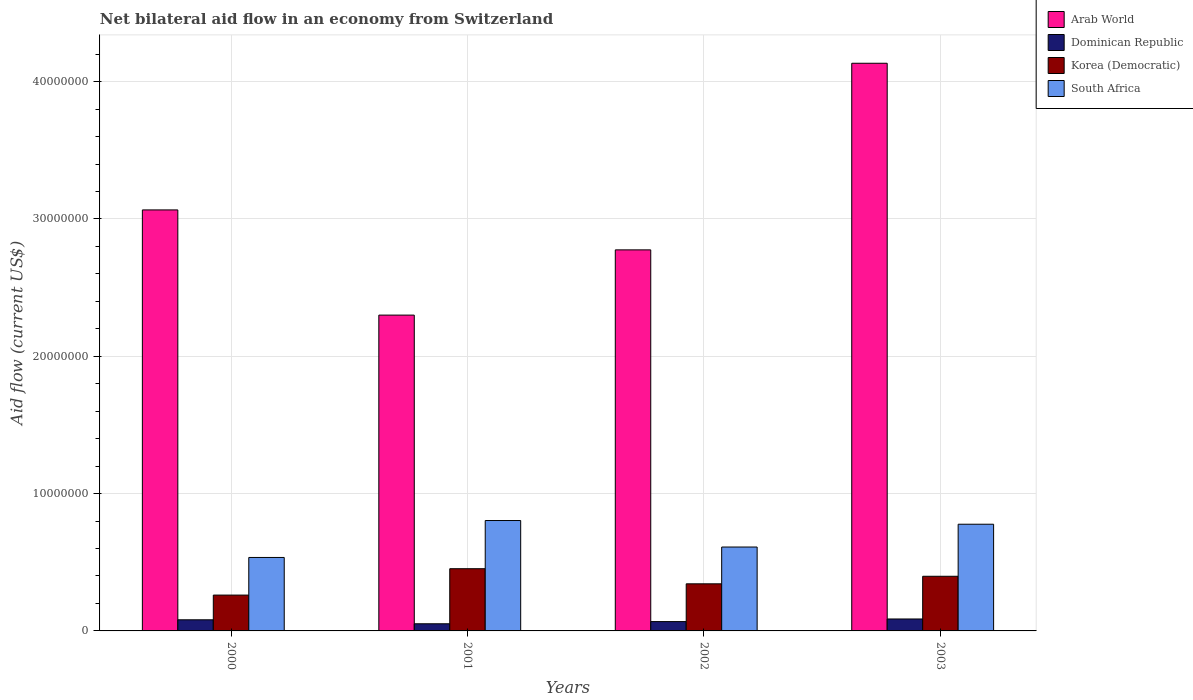How many different coloured bars are there?
Provide a succinct answer. 4. How many bars are there on the 1st tick from the left?
Ensure brevity in your answer.  4. In how many cases, is the number of bars for a given year not equal to the number of legend labels?
Provide a short and direct response. 0. What is the net bilateral aid flow in South Africa in 2002?
Your answer should be very brief. 6.11e+06. Across all years, what is the maximum net bilateral aid flow in South Africa?
Provide a short and direct response. 8.04e+06. Across all years, what is the minimum net bilateral aid flow in South Africa?
Keep it short and to the point. 5.35e+06. In which year was the net bilateral aid flow in Dominican Republic maximum?
Provide a succinct answer. 2003. In which year was the net bilateral aid flow in Korea (Democratic) minimum?
Your answer should be very brief. 2000. What is the total net bilateral aid flow in South Africa in the graph?
Offer a very short reply. 2.73e+07. What is the difference between the net bilateral aid flow in Korea (Democratic) in 2002 and that in 2003?
Offer a terse response. -5.50e+05. What is the difference between the net bilateral aid flow in South Africa in 2000 and the net bilateral aid flow in Arab World in 2003?
Your response must be concise. -3.60e+07. What is the average net bilateral aid flow in Arab World per year?
Your answer should be very brief. 3.07e+07. In the year 2000, what is the difference between the net bilateral aid flow in Dominican Republic and net bilateral aid flow in Arab World?
Offer a very short reply. -2.98e+07. In how many years, is the net bilateral aid flow in Korea (Democratic) greater than 4000000 US$?
Make the answer very short. 1. What is the ratio of the net bilateral aid flow in South Africa in 2001 to that in 2002?
Ensure brevity in your answer.  1.32. Is the net bilateral aid flow in Korea (Democratic) in 2001 less than that in 2003?
Your answer should be very brief. No. Is the difference between the net bilateral aid flow in Dominican Republic in 2000 and 2001 greater than the difference between the net bilateral aid flow in Arab World in 2000 and 2001?
Ensure brevity in your answer.  No. What is the difference between the highest and the lowest net bilateral aid flow in Korea (Democratic)?
Offer a terse response. 1.92e+06. What does the 3rd bar from the left in 2000 represents?
Your answer should be very brief. Korea (Democratic). What does the 1st bar from the right in 2003 represents?
Make the answer very short. South Africa. Is it the case that in every year, the sum of the net bilateral aid flow in South Africa and net bilateral aid flow in Dominican Republic is greater than the net bilateral aid flow in Korea (Democratic)?
Offer a very short reply. Yes. How many bars are there?
Offer a very short reply. 16. Are all the bars in the graph horizontal?
Offer a terse response. No. How many years are there in the graph?
Offer a terse response. 4. What is the difference between two consecutive major ticks on the Y-axis?
Your response must be concise. 1.00e+07. Are the values on the major ticks of Y-axis written in scientific E-notation?
Offer a terse response. No. Where does the legend appear in the graph?
Make the answer very short. Top right. How are the legend labels stacked?
Make the answer very short. Vertical. What is the title of the graph?
Make the answer very short. Net bilateral aid flow in an economy from Switzerland. What is the label or title of the Y-axis?
Your response must be concise. Aid flow (current US$). What is the Aid flow (current US$) in Arab World in 2000?
Your response must be concise. 3.07e+07. What is the Aid flow (current US$) of Dominican Republic in 2000?
Provide a short and direct response. 8.10e+05. What is the Aid flow (current US$) in Korea (Democratic) in 2000?
Make the answer very short. 2.61e+06. What is the Aid flow (current US$) of South Africa in 2000?
Your answer should be very brief. 5.35e+06. What is the Aid flow (current US$) in Arab World in 2001?
Ensure brevity in your answer.  2.30e+07. What is the Aid flow (current US$) of Dominican Republic in 2001?
Give a very brief answer. 5.20e+05. What is the Aid flow (current US$) of Korea (Democratic) in 2001?
Ensure brevity in your answer.  4.53e+06. What is the Aid flow (current US$) in South Africa in 2001?
Provide a short and direct response. 8.04e+06. What is the Aid flow (current US$) in Arab World in 2002?
Your answer should be very brief. 2.78e+07. What is the Aid flow (current US$) in Dominican Republic in 2002?
Ensure brevity in your answer.  6.80e+05. What is the Aid flow (current US$) in Korea (Democratic) in 2002?
Ensure brevity in your answer.  3.43e+06. What is the Aid flow (current US$) in South Africa in 2002?
Your answer should be very brief. 6.11e+06. What is the Aid flow (current US$) of Arab World in 2003?
Your answer should be compact. 4.13e+07. What is the Aid flow (current US$) in Dominican Republic in 2003?
Your answer should be very brief. 8.70e+05. What is the Aid flow (current US$) of Korea (Democratic) in 2003?
Your response must be concise. 3.98e+06. What is the Aid flow (current US$) in South Africa in 2003?
Your answer should be very brief. 7.77e+06. Across all years, what is the maximum Aid flow (current US$) in Arab World?
Keep it short and to the point. 4.13e+07. Across all years, what is the maximum Aid flow (current US$) in Dominican Republic?
Offer a terse response. 8.70e+05. Across all years, what is the maximum Aid flow (current US$) in Korea (Democratic)?
Provide a succinct answer. 4.53e+06. Across all years, what is the maximum Aid flow (current US$) in South Africa?
Offer a very short reply. 8.04e+06. Across all years, what is the minimum Aid flow (current US$) in Arab World?
Offer a terse response. 2.30e+07. Across all years, what is the minimum Aid flow (current US$) in Dominican Republic?
Your answer should be compact. 5.20e+05. Across all years, what is the minimum Aid flow (current US$) of Korea (Democratic)?
Offer a very short reply. 2.61e+06. Across all years, what is the minimum Aid flow (current US$) of South Africa?
Your response must be concise. 5.35e+06. What is the total Aid flow (current US$) in Arab World in the graph?
Give a very brief answer. 1.23e+08. What is the total Aid flow (current US$) of Dominican Republic in the graph?
Make the answer very short. 2.88e+06. What is the total Aid flow (current US$) in Korea (Democratic) in the graph?
Provide a short and direct response. 1.46e+07. What is the total Aid flow (current US$) in South Africa in the graph?
Keep it short and to the point. 2.73e+07. What is the difference between the Aid flow (current US$) of Arab World in 2000 and that in 2001?
Your answer should be compact. 7.66e+06. What is the difference between the Aid flow (current US$) in Dominican Republic in 2000 and that in 2001?
Your answer should be very brief. 2.90e+05. What is the difference between the Aid flow (current US$) of Korea (Democratic) in 2000 and that in 2001?
Give a very brief answer. -1.92e+06. What is the difference between the Aid flow (current US$) of South Africa in 2000 and that in 2001?
Your answer should be compact. -2.69e+06. What is the difference between the Aid flow (current US$) in Arab World in 2000 and that in 2002?
Your answer should be very brief. 2.91e+06. What is the difference between the Aid flow (current US$) in Korea (Democratic) in 2000 and that in 2002?
Provide a short and direct response. -8.20e+05. What is the difference between the Aid flow (current US$) in South Africa in 2000 and that in 2002?
Offer a very short reply. -7.60e+05. What is the difference between the Aid flow (current US$) in Arab World in 2000 and that in 2003?
Your answer should be compact. -1.07e+07. What is the difference between the Aid flow (current US$) of Korea (Democratic) in 2000 and that in 2003?
Provide a short and direct response. -1.37e+06. What is the difference between the Aid flow (current US$) in South Africa in 2000 and that in 2003?
Keep it short and to the point. -2.42e+06. What is the difference between the Aid flow (current US$) in Arab World in 2001 and that in 2002?
Your answer should be very brief. -4.75e+06. What is the difference between the Aid flow (current US$) in Korea (Democratic) in 2001 and that in 2002?
Your answer should be very brief. 1.10e+06. What is the difference between the Aid flow (current US$) in South Africa in 2001 and that in 2002?
Give a very brief answer. 1.93e+06. What is the difference between the Aid flow (current US$) in Arab World in 2001 and that in 2003?
Offer a terse response. -1.83e+07. What is the difference between the Aid flow (current US$) in Dominican Republic in 2001 and that in 2003?
Provide a short and direct response. -3.50e+05. What is the difference between the Aid flow (current US$) in Arab World in 2002 and that in 2003?
Your answer should be very brief. -1.36e+07. What is the difference between the Aid flow (current US$) in Korea (Democratic) in 2002 and that in 2003?
Offer a very short reply. -5.50e+05. What is the difference between the Aid flow (current US$) of South Africa in 2002 and that in 2003?
Keep it short and to the point. -1.66e+06. What is the difference between the Aid flow (current US$) in Arab World in 2000 and the Aid flow (current US$) in Dominican Republic in 2001?
Make the answer very short. 3.01e+07. What is the difference between the Aid flow (current US$) of Arab World in 2000 and the Aid flow (current US$) of Korea (Democratic) in 2001?
Your answer should be very brief. 2.61e+07. What is the difference between the Aid flow (current US$) in Arab World in 2000 and the Aid flow (current US$) in South Africa in 2001?
Give a very brief answer. 2.26e+07. What is the difference between the Aid flow (current US$) of Dominican Republic in 2000 and the Aid flow (current US$) of Korea (Democratic) in 2001?
Provide a succinct answer. -3.72e+06. What is the difference between the Aid flow (current US$) of Dominican Republic in 2000 and the Aid flow (current US$) of South Africa in 2001?
Offer a very short reply. -7.23e+06. What is the difference between the Aid flow (current US$) of Korea (Democratic) in 2000 and the Aid flow (current US$) of South Africa in 2001?
Keep it short and to the point. -5.43e+06. What is the difference between the Aid flow (current US$) in Arab World in 2000 and the Aid flow (current US$) in Dominican Republic in 2002?
Your answer should be compact. 3.00e+07. What is the difference between the Aid flow (current US$) of Arab World in 2000 and the Aid flow (current US$) of Korea (Democratic) in 2002?
Keep it short and to the point. 2.72e+07. What is the difference between the Aid flow (current US$) of Arab World in 2000 and the Aid flow (current US$) of South Africa in 2002?
Provide a short and direct response. 2.46e+07. What is the difference between the Aid flow (current US$) in Dominican Republic in 2000 and the Aid flow (current US$) in Korea (Democratic) in 2002?
Provide a succinct answer. -2.62e+06. What is the difference between the Aid flow (current US$) in Dominican Republic in 2000 and the Aid flow (current US$) in South Africa in 2002?
Your answer should be very brief. -5.30e+06. What is the difference between the Aid flow (current US$) in Korea (Democratic) in 2000 and the Aid flow (current US$) in South Africa in 2002?
Your response must be concise. -3.50e+06. What is the difference between the Aid flow (current US$) in Arab World in 2000 and the Aid flow (current US$) in Dominican Republic in 2003?
Keep it short and to the point. 2.98e+07. What is the difference between the Aid flow (current US$) in Arab World in 2000 and the Aid flow (current US$) in Korea (Democratic) in 2003?
Your response must be concise. 2.67e+07. What is the difference between the Aid flow (current US$) in Arab World in 2000 and the Aid flow (current US$) in South Africa in 2003?
Give a very brief answer. 2.29e+07. What is the difference between the Aid flow (current US$) of Dominican Republic in 2000 and the Aid flow (current US$) of Korea (Democratic) in 2003?
Offer a very short reply. -3.17e+06. What is the difference between the Aid flow (current US$) of Dominican Republic in 2000 and the Aid flow (current US$) of South Africa in 2003?
Offer a very short reply. -6.96e+06. What is the difference between the Aid flow (current US$) in Korea (Democratic) in 2000 and the Aid flow (current US$) in South Africa in 2003?
Provide a succinct answer. -5.16e+06. What is the difference between the Aid flow (current US$) in Arab World in 2001 and the Aid flow (current US$) in Dominican Republic in 2002?
Offer a terse response. 2.23e+07. What is the difference between the Aid flow (current US$) of Arab World in 2001 and the Aid flow (current US$) of Korea (Democratic) in 2002?
Keep it short and to the point. 1.96e+07. What is the difference between the Aid flow (current US$) of Arab World in 2001 and the Aid flow (current US$) of South Africa in 2002?
Your answer should be very brief. 1.69e+07. What is the difference between the Aid flow (current US$) of Dominican Republic in 2001 and the Aid flow (current US$) of Korea (Democratic) in 2002?
Make the answer very short. -2.91e+06. What is the difference between the Aid flow (current US$) of Dominican Republic in 2001 and the Aid flow (current US$) of South Africa in 2002?
Keep it short and to the point. -5.59e+06. What is the difference between the Aid flow (current US$) in Korea (Democratic) in 2001 and the Aid flow (current US$) in South Africa in 2002?
Offer a terse response. -1.58e+06. What is the difference between the Aid flow (current US$) of Arab World in 2001 and the Aid flow (current US$) of Dominican Republic in 2003?
Make the answer very short. 2.21e+07. What is the difference between the Aid flow (current US$) in Arab World in 2001 and the Aid flow (current US$) in Korea (Democratic) in 2003?
Provide a short and direct response. 1.90e+07. What is the difference between the Aid flow (current US$) in Arab World in 2001 and the Aid flow (current US$) in South Africa in 2003?
Ensure brevity in your answer.  1.52e+07. What is the difference between the Aid flow (current US$) in Dominican Republic in 2001 and the Aid flow (current US$) in Korea (Democratic) in 2003?
Your answer should be compact. -3.46e+06. What is the difference between the Aid flow (current US$) in Dominican Republic in 2001 and the Aid flow (current US$) in South Africa in 2003?
Offer a terse response. -7.25e+06. What is the difference between the Aid flow (current US$) of Korea (Democratic) in 2001 and the Aid flow (current US$) of South Africa in 2003?
Offer a very short reply. -3.24e+06. What is the difference between the Aid flow (current US$) of Arab World in 2002 and the Aid flow (current US$) of Dominican Republic in 2003?
Your answer should be very brief. 2.69e+07. What is the difference between the Aid flow (current US$) in Arab World in 2002 and the Aid flow (current US$) in Korea (Democratic) in 2003?
Provide a succinct answer. 2.38e+07. What is the difference between the Aid flow (current US$) of Arab World in 2002 and the Aid flow (current US$) of South Africa in 2003?
Give a very brief answer. 2.00e+07. What is the difference between the Aid flow (current US$) of Dominican Republic in 2002 and the Aid flow (current US$) of Korea (Democratic) in 2003?
Ensure brevity in your answer.  -3.30e+06. What is the difference between the Aid flow (current US$) in Dominican Republic in 2002 and the Aid flow (current US$) in South Africa in 2003?
Make the answer very short. -7.09e+06. What is the difference between the Aid flow (current US$) of Korea (Democratic) in 2002 and the Aid flow (current US$) of South Africa in 2003?
Give a very brief answer. -4.34e+06. What is the average Aid flow (current US$) of Arab World per year?
Your response must be concise. 3.07e+07. What is the average Aid flow (current US$) in Dominican Republic per year?
Offer a terse response. 7.20e+05. What is the average Aid flow (current US$) of Korea (Democratic) per year?
Make the answer very short. 3.64e+06. What is the average Aid flow (current US$) in South Africa per year?
Offer a terse response. 6.82e+06. In the year 2000, what is the difference between the Aid flow (current US$) of Arab World and Aid flow (current US$) of Dominican Republic?
Keep it short and to the point. 2.98e+07. In the year 2000, what is the difference between the Aid flow (current US$) in Arab World and Aid flow (current US$) in Korea (Democratic)?
Your answer should be compact. 2.80e+07. In the year 2000, what is the difference between the Aid flow (current US$) in Arab World and Aid flow (current US$) in South Africa?
Make the answer very short. 2.53e+07. In the year 2000, what is the difference between the Aid flow (current US$) of Dominican Republic and Aid flow (current US$) of Korea (Democratic)?
Your answer should be compact. -1.80e+06. In the year 2000, what is the difference between the Aid flow (current US$) in Dominican Republic and Aid flow (current US$) in South Africa?
Ensure brevity in your answer.  -4.54e+06. In the year 2000, what is the difference between the Aid flow (current US$) of Korea (Democratic) and Aid flow (current US$) of South Africa?
Give a very brief answer. -2.74e+06. In the year 2001, what is the difference between the Aid flow (current US$) of Arab World and Aid flow (current US$) of Dominican Republic?
Provide a succinct answer. 2.25e+07. In the year 2001, what is the difference between the Aid flow (current US$) in Arab World and Aid flow (current US$) in Korea (Democratic)?
Provide a succinct answer. 1.85e+07. In the year 2001, what is the difference between the Aid flow (current US$) in Arab World and Aid flow (current US$) in South Africa?
Your answer should be very brief. 1.50e+07. In the year 2001, what is the difference between the Aid flow (current US$) in Dominican Republic and Aid flow (current US$) in Korea (Democratic)?
Keep it short and to the point. -4.01e+06. In the year 2001, what is the difference between the Aid flow (current US$) in Dominican Republic and Aid flow (current US$) in South Africa?
Make the answer very short. -7.52e+06. In the year 2001, what is the difference between the Aid flow (current US$) in Korea (Democratic) and Aid flow (current US$) in South Africa?
Your answer should be compact. -3.51e+06. In the year 2002, what is the difference between the Aid flow (current US$) in Arab World and Aid flow (current US$) in Dominican Republic?
Offer a very short reply. 2.71e+07. In the year 2002, what is the difference between the Aid flow (current US$) of Arab World and Aid flow (current US$) of Korea (Democratic)?
Make the answer very short. 2.43e+07. In the year 2002, what is the difference between the Aid flow (current US$) of Arab World and Aid flow (current US$) of South Africa?
Provide a short and direct response. 2.16e+07. In the year 2002, what is the difference between the Aid flow (current US$) in Dominican Republic and Aid flow (current US$) in Korea (Democratic)?
Offer a very short reply. -2.75e+06. In the year 2002, what is the difference between the Aid flow (current US$) of Dominican Republic and Aid flow (current US$) of South Africa?
Provide a succinct answer. -5.43e+06. In the year 2002, what is the difference between the Aid flow (current US$) of Korea (Democratic) and Aid flow (current US$) of South Africa?
Make the answer very short. -2.68e+06. In the year 2003, what is the difference between the Aid flow (current US$) in Arab World and Aid flow (current US$) in Dominican Republic?
Make the answer very short. 4.05e+07. In the year 2003, what is the difference between the Aid flow (current US$) of Arab World and Aid flow (current US$) of Korea (Democratic)?
Keep it short and to the point. 3.74e+07. In the year 2003, what is the difference between the Aid flow (current US$) in Arab World and Aid flow (current US$) in South Africa?
Offer a terse response. 3.36e+07. In the year 2003, what is the difference between the Aid flow (current US$) of Dominican Republic and Aid flow (current US$) of Korea (Democratic)?
Offer a very short reply. -3.11e+06. In the year 2003, what is the difference between the Aid flow (current US$) of Dominican Republic and Aid flow (current US$) of South Africa?
Keep it short and to the point. -6.90e+06. In the year 2003, what is the difference between the Aid flow (current US$) in Korea (Democratic) and Aid flow (current US$) in South Africa?
Keep it short and to the point. -3.79e+06. What is the ratio of the Aid flow (current US$) of Arab World in 2000 to that in 2001?
Give a very brief answer. 1.33. What is the ratio of the Aid flow (current US$) in Dominican Republic in 2000 to that in 2001?
Give a very brief answer. 1.56. What is the ratio of the Aid flow (current US$) in Korea (Democratic) in 2000 to that in 2001?
Provide a short and direct response. 0.58. What is the ratio of the Aid flow (current US$) in South Africa in 2000 to that in 2001?
Your answer should be very brief. 0.67. What is the ratio of the Aid flow (current US$) of Arab World in 2000 to that in 2002?
Make the answer very short. 1.1. What is the ratio of the Aid flow (current US$) in Dominican Republic in 2000 to that in 2002?
Give a very brief answer. 1.19. What is the ratio of the Aid flow (current US$) of Korea (Democratic) in 2000 to that in 2002?
Offer a terse response. 0.76. What is the ratio of the Aid flow (current US$) in South Africa in 2000 to that in 2002?
Your answer should be very brief. 0.88. What is the ratio of the Aid flow (current US$) in Arab World in 2000 to that in 2003?
Your answer should be compact. 0.74. What is the ratio of the Aid flow (current US$) in Dominican Republic in 2000 to that in 2003?
Give a very brief answer. 0.93. What is the ratio of the Aid flow (current US$) of Korea (Democratic) in 2000 to that in 2003?
Provide a short and direct response. 0.66. What is the ratio of the Aid flow (current US$) in South Africa in 2000 to that in 2003?
Give a very brief answer. 0.69. What is the ratio of the Aid flow (current US$) of Arab World in 2001 to that in 2002?
Give a very brief answer. 0.83. What is the ratio of the Aid flow (current US$) in Dominican Republic in 2001 to that in 2002?
Offer a very short reply. 0.76. What is the ratio of the Aid flow (current US$) of Korea (Democratic) in 2001 to that in 2002?
Your response must be concise. 1.32. What is the ratio of the Aid flow (current US$) in South Africa in 2001 to that in 2002?
Make the answer very short. 1.32. What is the ratio of the Aid flow (current US$) of Arab World in 2001 to that in 2003?
Your answer should be compact. 0.56. What is the ratio of the Aid flow (current US$) in Dominican Republic in 2001 to that in 2003?
Provide a succinct answer. 0.6. What is the ratio of the Aid flow (current US$) in Korea (Democratic) in 2001 to that in 2003?
Provide a succinct answer. 1.14. What is the ratio of the Aid flow (current US$) of South Africa in 2001 to that in 2003?
Make the answer very short. 1.03. What is the ratio of the Aid flow (current US$) of Arab World in 2002 to that in 2003?
Offer a very short reply. 0.67. What is the ratio of the Aid flow (current US$) in Dominican Republic in 2002 to that in 2003?
Make the answer very short. 0.78. What is the ratio of the Aid flow (current US$) in Korea (Democratic) in 2002 to that in 2003?
Offer a very short reply. 0.86. What is the ratio of the Aid flow (current US$) in South Africa in 2002 to that in 2003?
Give a very brief answer. 0.79. What is the difference between the highest and the second highest Aid flow (current US$) of Arab World?
Provide a succinct answer. 1.07e+07. What is the difference between the highest and the second highest Aid flow (current US$) of Korea (Democratic)?
Your response must be concise. 5.50e+05. What is the difference between the highest and the lowest Aid flow (current US$) of Arab World?
Provide a short and direct response. 1.83e+07. What is the difference between the highest and the lowest Aid flow (current US$) in Korea (Democratic)?
Make the answer very short. 1.92e+06. What is the difference between the highest and the lowest Aid flow (current US$) in South Africa?
Your answer should be compact. 2.69e+06. 